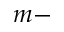<formula> <loc_0><loc_0><loc_500><loc_500>m -</formula> 